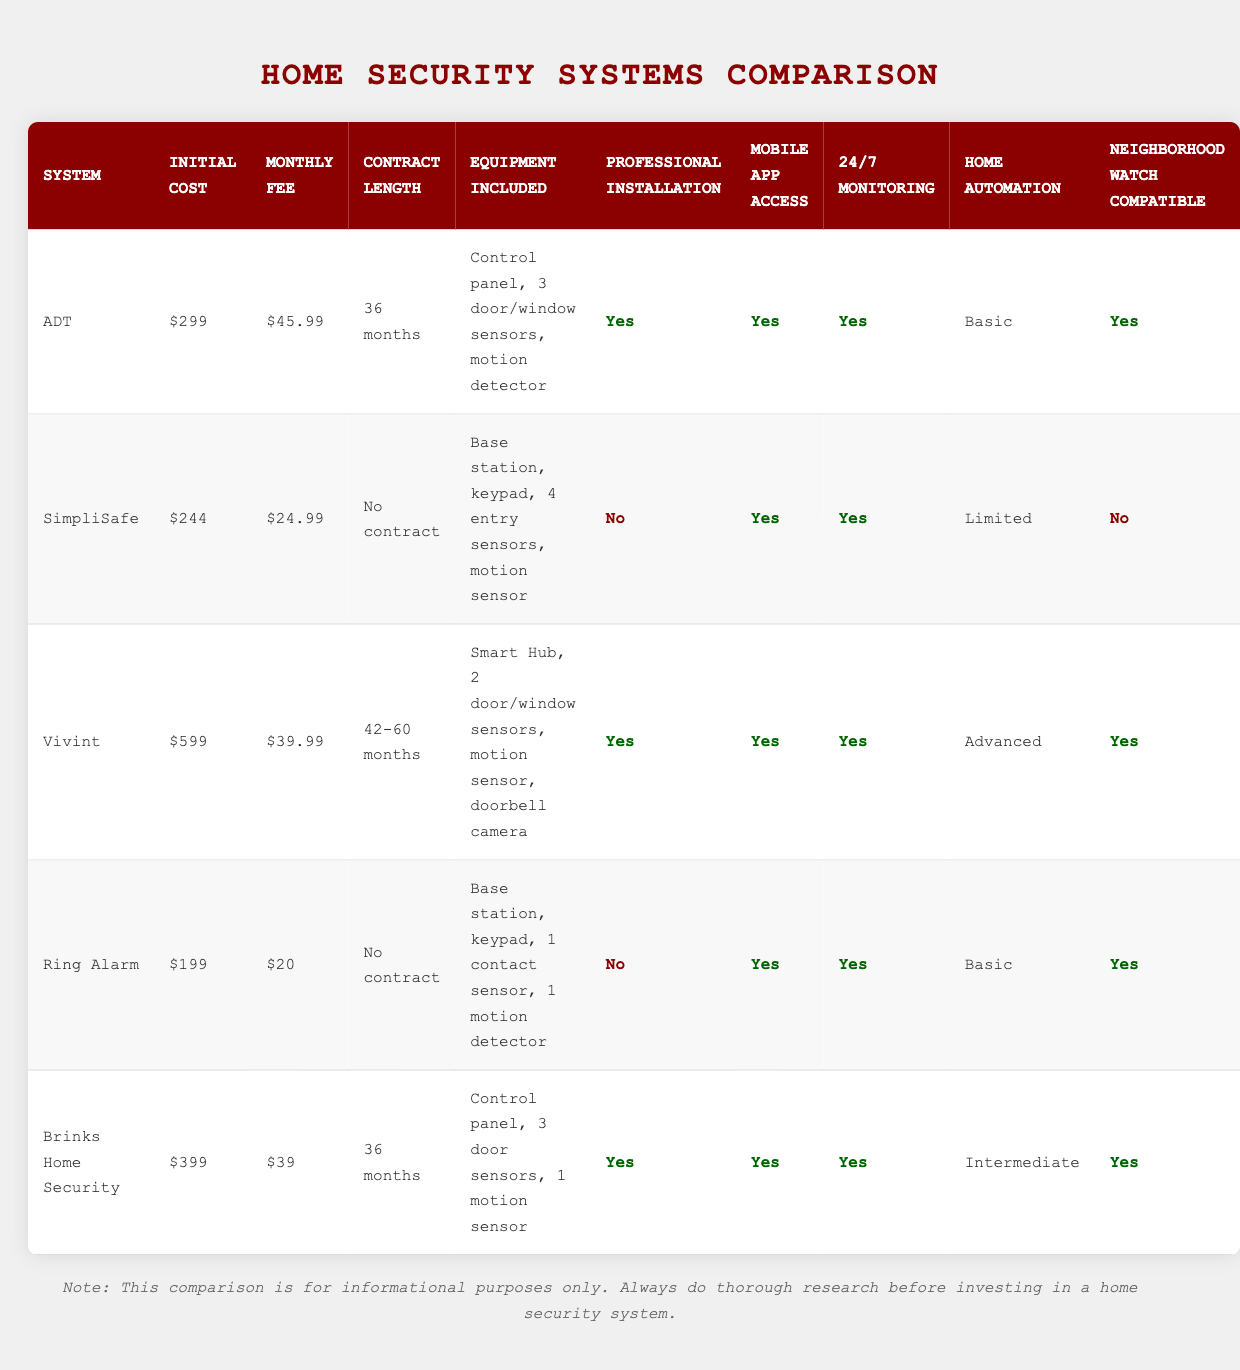What is the initial cost of the SimpliSafe security system? The initial cost for the SimpliSafe is listed in the table under the "Initial Cost" column, which shows $244 for this system.
Answer: $244 How much does the Ring Alarm charge monthly? The monthly fee for Ring Alarm is specified in the "Monthly Fee" column of the table, which is $20.
Answer: $20 Which security system offers professional installation? By reviewing the "Professional Installation" column, we can see that ADT, Vivint, and Brinks Home Security offer professional installation, indicated by "Yes."
Answer: ADT, Vivint, Brinks Home Security What is the average monthly fee of all the systems listed? To find the average, we sum the monthly fees: (45.99 + 24.99 + 39.99 + 20 + 39) = 170.97, and then divide by the number of systems (5), giving 170.97 / 5 = 34.194. Therefore, the average monthly fee is approximately $34.19.
Answer: $34.19 Is Vivint compatible with neighborhood watch programs? Looking at the "Neighborhood Watch Compatible" column, it shows that Vivint has a "Yes" in that section, meaning it is compatible with neighborhood watch programs.
Answer: Yes What is the difference in initial cost between the most expensive and the least expensive security systems? The most expensive system is Vivint at $599, and the least expensive is Ring Alarm at $199. The difference is calculated as $599 - $199 = $400.
Answer: $400 Which system has the longest contract length? By examining the "Contract Length" column, Vivint offers a contract length of 42-60 months, which is longer than any other system listed, which mostly have either 36 months or no contract.
Answer: Vivint Do all systems provide 24/7 monitoring? We check the "24/7 Monitoring" column for each system; ADT, SimpliSafe, Vivint, Ring Alarm, and Brinks Home Security all have a "Yes," indicating that all systems provide this feature.
Answer: Yes 